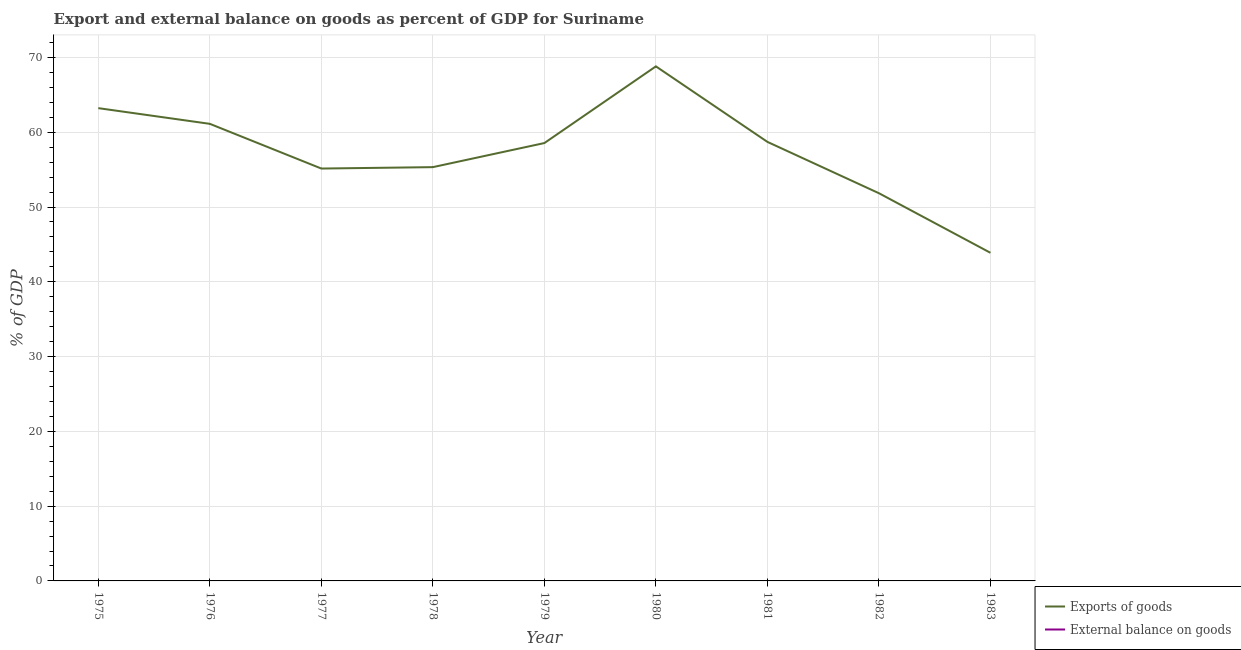How many different coloured lines are there?
Provide a short and direct response. 1. Across all years, what is the maximum export of goods as percentage of gdp?
Provide a succinct answer. 68.81. Across all years, what is the minimum external balance on goods as percentage of gdp?
Keep it short and to the point. 0. In which year was the export of goods as percentage of gdp maximum?
Ensure brevity in your answer.  1980. What is the total external balance on goods as percentage of gdp in the graph?
Ensure brevity in your answer.  0. What is the difference between the export of goods as percentage of gdp in 1978 and that in 1983?
Your response must be concise. 11.45. What is the difference between the export of goods as percentage of gdp in 1977 and the external balance on goods as percentage of gdp in 1975?
Offer a very short reply. 55.15. What is the average external balance on goods as percentage of gdp per year?
Your response must be concise. 0. What is the ratio of the export of goods as percentage of gdp in 1978 to that in 1983?
Keep it short and to the point. 1.26. What is the difference between the highest and the second highest export of goods as percentage of gdp?
Provide a short and direct response. 5.59. What is the difference between the highest and the lowest export of goods as percentage of gdp?
Give a very brief answer. 24.93. In how many years, is the export of goods as percentage of gdp greater than the average export of goods as percentage of gdp taken over all years?
Your answer should be compact. 5. Is the sum of the export of goods as percentage of gdp in 1979 and 1982 greater than the maximum external balance on goods as percentage of gdp across all years?
Offer a very short reply. Yes. How many lines are there?
Your answer should be very brief. 1. Does the graph contain any zero values?
Your answer should be compact. Yes. Does the graph contain grids?
Ensure brevity in your answer.  Yes. Where does the legend appear in the graph?
Ensure brevity in your answer.  Bottom right. How many legend labels are there?
Provide a succinct answer. 2. How are the legend labels stacked?
Provide a short and direct response. Vertical. What is the title of the graph?
Give a very brief answer. Export and external balance on goods as percent of GDP for Suriname. What is the label or title of the Y-axis?
Make the answer very short. % of GDP. What is the % of GDP of Exports of goods in 1975?
Make the answer very short. 63.23. What is the % of GDP of Exports of goods in 1976?
Give a very brief answer. 61.13. What is the % of GDP in External balance on goods in 1976?
Give a very brief answer. 0. What is the % of GDP in Exports of goods in 1977?
Provide a short and direct response. 55.15. What is the % of GDP in Exports of goods in 1978?
Provide a short and direct response. 55.34. What is the % of GDP of External balance on goods in 1978?
Your answer should be very brief. 0. What is the % of GDP of Exports of goods in 1979?
Offer a terse response. 58.56. What is the % of GDP in External balance on goods in 1979?
Offer a very short reply. 0. What is the % of GDP in Exports of goods in 1980?
Your answer should be compact. 68.81. What is the % of GDP in External balance on goods in 1980?
Provide a short and direct response. 0. What is the % of GDP in Exports of goods in 1981?
Keep it short and to the point. 58.71. What is the % of GDP in Exports of goods in 1982?
Provide a short and direct response. 51.85. What is the % of GDP of Exports of goods in 1983?
Ensure brevity in your answer.  43.88. What is the % of GDP of External balance on goods in 1983?
Provide a short and direct response. 0. Across all years, what is the maximum % of GDP in Exports of goods?
Make the answer very short. 68.81. Across all years, what is the minimum % of GDP in Exports of goods?
Offer a terse response. 43.88. What is the total % of GDP in Exports of goods in the graph?
Your response must be concise. 516.66. What is the difference between the % of GDP of Exports of goods in 1975 and that in 1976?
Ensure brevity in your answer.  2.1. What is the difference between the % of GDP of Exports of goods in 1975 and that in 1977?
Give a very brief answer. 8.08. What is the difference between the % of GDP of Exports of goods in 1975 and that in 1978?
Your response must be concise. 7.89. What is the difference between the % of GDP of Exports of goods in 1975 and that in 1979?
Keep it short and to the point. 4.67. What is the difference between the % of GDP of Exports of goods in 1975 and that in 1980?
Make the answer very short. -5.59. What is the difference between the % of GDP of Exports of goods in 1975 and that in 1981?
Make the answer very short. 4.51. What is the difference between the % of GDP in Exports of goods in 1975 and that in 1982?
Your answer should be very brief. 11.38. What is the difference between the % of GDP in Exports of goods in 1975 and that in 1983?
Your answer should be very brief. 19.34. What is the difference between the % of GDP of Exports of goods in 1976 and that in 1977?
Your answer should be very brief. 5.98. What is the difference between the % of GDP in Exports of goods in 1976 and that in 1978?
Your answer should be very brief. 5.79. What is the difference between the % of GDP in Exports of goods in 1976 and that in 1979?
Your answer should be compact. 2.57. What is the difference between the % of GDP of Exports of goods in 1976 and that in 1980?
Make the answer very short. -7.69. What is the difference between the % of GDP in Exports of goods in 1976 and that in 1981?
Your response must be concise. 2.41. What is the difference between the % of GDP in Exports of goods in 1976 and that in 1982?
Offer a terse response. 9.28. What is the difference between the % of GDP in Exports of goods in 1976 and that in 1983?
Give a very brief answer. 17.24. What is the difference between the % of GDP in Exports of goods in 1977 and that in 1978?
Your response must be concise. -0.19. What is the difference between the % of GDP of Exports of goods in 1977 and that in 1979?
Give a very brief answer. -3.41. What is the difference between the % of GDP in Exports of goods in 1977 and that in 1980?
Ensure brevity in your answer.  -13.67. What is the difference between the % of GDP of Exports of goods in 1977 and that in 1981?
Your answer should be compact. -3.57. What is the difference between the % of GDP of Exports of goods in 1977 and that in 1982?
Offer a terse response. 3.3. What is the difference between the % of GDP in Exports of goods in 1977 and that in 1983?
Provide a short and direct response. 11.27. What is the difference between the % of GDP in Exports of goods in 1978 and that in 1979?
Ensure brevity in your answer.  -3.22. What is the difference between the % of GDP in Exports of goods in 1978 and that in 1980?
Your response must be concise. -13.48. What is the difference between the % of GDP of Exports of goods in 1978 and that in 1981?
Your response must be concise. -3.38. What is the difference between the % of GDP in Exports of goods in 1978 and that in 1982?
Ensure brevity in your answer.  3.49. What is the difference between the % of GDP in Exports of goods in 1978 and that in 1983?
Make the answer very short. 11.45. What is the difference between the % of GDP of Exports of goods in 1979 and that in 1980?
Your answer should be compact. -10.26. What is the difference between the % of GDP in Exports of goods in 1979 and that in 1981?
Make the answer very short. -0.16. What is the difference between the % of GDP in Exports of goods in 1979 and that in 1982?
Your answer should be very brief. 6.71. What is the difference between the % of GDP in Exports of goods in 1979 and that in 1983?
Ensure brevity in your answer.  14.67. What is the difference between the % of GDP of Exports of goods in 1980 and that in 1981?
Provide a short and direct response. 10.1. What is the difference between the % of GDP of Exports of goods in 1980 and that in 1982?
Ensure brevity in your answer.  16.96. What is the difference between the % of GDP in Exports of goods in 1980 and that in 1983?
Your answer should be very brief. 24.93. What is the difference between the % of GDP in Exports of goods in 1981 and that in 1982?
Offer a very short reply. 6.86. What is the difference between the % of GDP of Exports of goods in 1981 and that in 1983?
Your response must be concise. 14.83. What is the difference between the % of GDP of Exports of goods in 1982 and that in 1983?
Give a very brief answer. 7.97. What is the average % of GDP in Exports of goods per year?
Your answer should be very brief. 57.41. What is the average % of GDP of External balance on goods per year?
Offer a very short reply. 0. What is the ratio of the % of GDP in Exports of goods in 1975 to that in 1976?
Your response must be concise. 1.03. What is the ratio of the % of GDP of Exports of goods in 1975 to that in 1977?
Offer a terse response. 1.15. What is the ratio of the % of GDP of Exports of goods in 1975 to that in 1978?
Offer a very short reply. 1.14. What is the ratio of the % of GDP in Exports of goods in 1975 to that in 1979?
Offer a very short reply. 1.08. What is the ratio of the % of GDP of Exports of goods in 1975 to that in 1980?
Keep it short and to the point. 0.92. What is the ratio of the % of GDP of Exports of goods in 1975 to that in 1981?
Ensure brevity in your answer.  1.08. What is the ratio of the % of GDP of Exports of goods in 1975 to that in 1982?
Make the answer very short. 1.22. What is the ratio of the % of GDP in Exports of goods in 1975 to that in 1983?
Offer a terse response. 1.44. What is the ratio of the % of GDP of Exports of goods in 1976 to that in 1977?
Offer a terse response. 1.11. What is the ratio of the % of GDP of Exports of goods in 1976 to that in 1978?
Offer a terse response. 1.1. What is the ratio of the % of GDP in Exports of goods in 1976 to that in 1979?
Give a very brief answer. 1.04. What is the ratio of the % of GDP of Exports of goods in 1976 to that in 1980?
Provide a short and direct response. 0.89. What is the ratio of the % of GDP of Exports of goods in 1976 to that in 1981?
Keep it short and to the point. 1.04. What is the ratio of the % of GDP in Exports of goods in 1976 to that in 1982?
Offer a very short reply. 1.18. What is the ratio of the % of GDP in Exports of goods in 1976 to that in 1983?
Provide a short and direct response. 1.39. What is the ratio of the % of GDP of Exports of goods in 1977 to that in 1979?
Your answer should be compact. 0.94. What is the ratio of the % of GDP of Exports of goods in 1977 to that in 1980?
Offer a very short reply. 0.8. What is the ratio of the % of GDP of Exports of goods in 1977 to that in 1981?
Offer a terse response. 0.94. What is the ratio of the % of GDP in Exports of goods in 1977 to that in 1982?
Provide a succinct answer. 1.06. What is the ratio of the % of GDP of Exports of goods in 1977 to that in 1983?
Offer a very short reply. 1.26. What is the ratio of the % of GDP in Exports of goods in 1978 to that in 1979?
Keep it short and to the point. 0.94. What is the ratio of the % of GDP in Exports of goods in 1978 to that in 1980?
Give a very brief answer. 0.8. What is the ratio of the % of GDP in Exports of goods in 1978 to that in 1981?
Ensure brevity in your answer.  0.94. What is the ratio of the % of GDP in Exports of goods in 1978 to that in 1982?
Keep it short and to the point. 1.07. What is the ratio of the % of GDP in Exports of goods in 1978 to that in 1983?
Your answer should be compact. 1.26. What is the ratio of the % of GDP of Exports of goods in 1979 to that in 1980?
Provide a short and direct response. 0.85. What is the ratio of the % of GDP of Exports of goods in 1979 to that in 1982?
Offer a terse response. 1.13. What is the ratio of the % of GDP of Exports of goods in 1979 to that in 1983?
Keep it short and to the point. 1.33. What is the ratio of the % of GDP in Exports of goods in 1980 to that in 1981?
Offer a very short reply. 1.17. What is the ratio of the % of GDP in Exports of goods in 1980 to that in 1982?
Your answer should be very brief. 1.33. What is the ratio of the % of GDP of Exports of goods in 1980 to that in 1983?
Your answer should be very brief. 1.57. What is the ratio of the % of GDP in Exports of goods in 1981 to that in 1982?
Provide a short and direct response. 1.13. What is the ratio of the % of GDP in Exports of goods in 1981 to that in 1983?
Keep it short and to the point. 1.34. What is the ratio of the % of GDP of Exports of goods in 1982 to that in 1983?
Make the answer very short. 1.18. What is the difference between the highest and the second highest % of GDP in Exports of goods?
Your answer should be compact. 5.59. What is the difference between the highest and the lowest % of GDP in Exports of goods?
Provide a short and direct response. 24.93. 